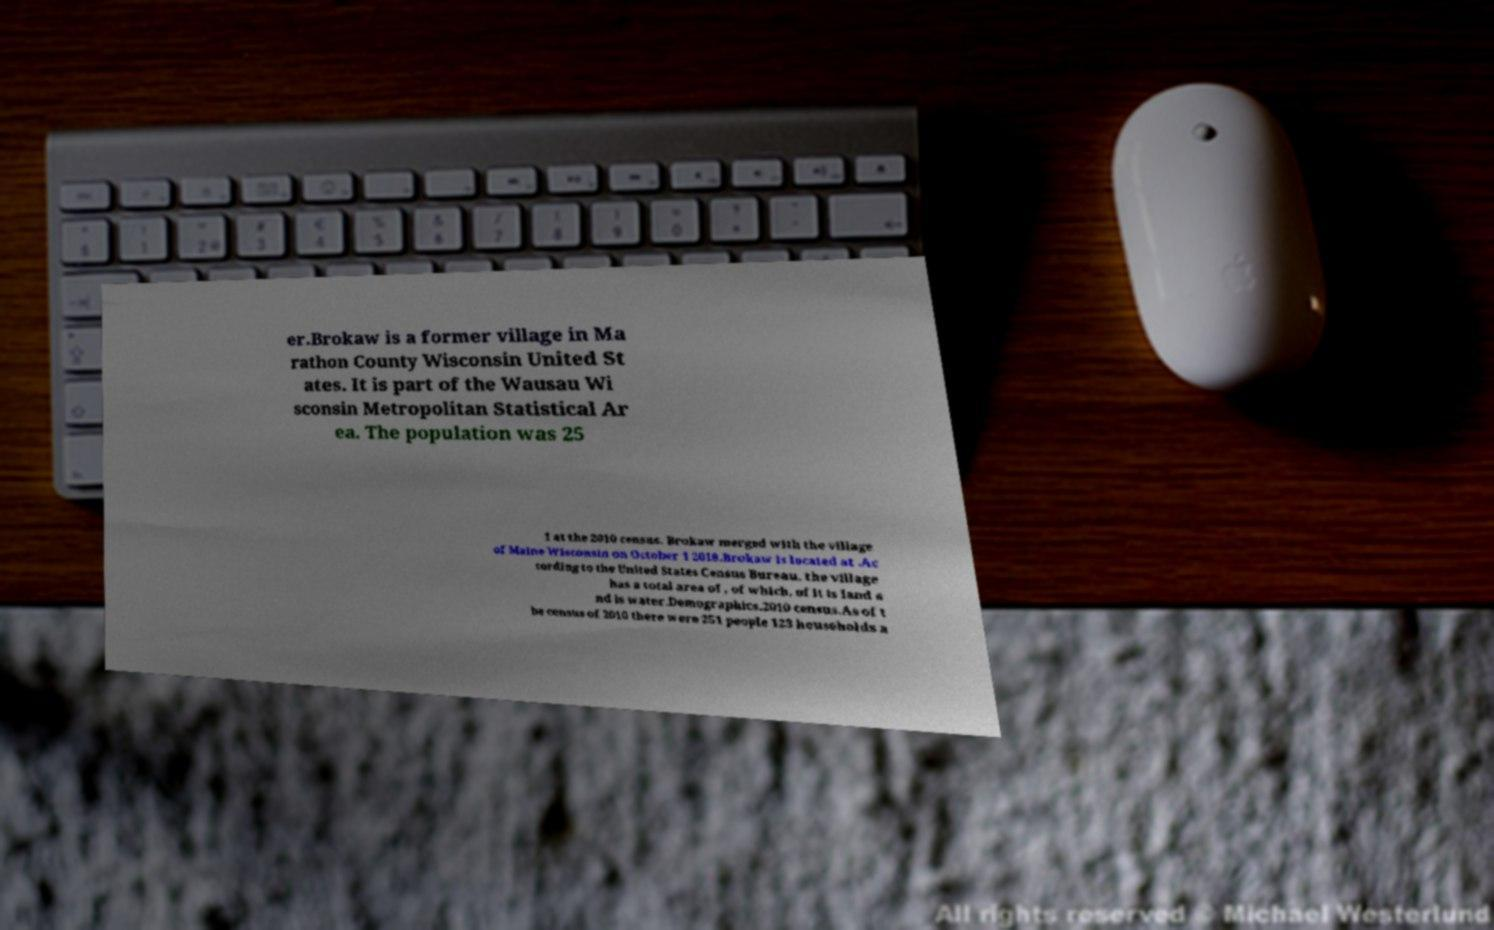Please read and relay the text visible in this image. What does it say? er.Brokaw is a former village in Ma rathon County Wisconsin United St ates. It is part of the Wausau Wi sconsin Metropolitan Statistical Ar ea. The population was 25 1 at the 2010 census. Brokaw merged with the village of Maine Wisconsin on October 1 2018.Brokaw is located at .Ac cording to the United States Census Bureau, the village has a total area of , of which, of it is land a nd is water.Demographics.2010 census.As of t he census of 2010 there were 251 people 123 households a 